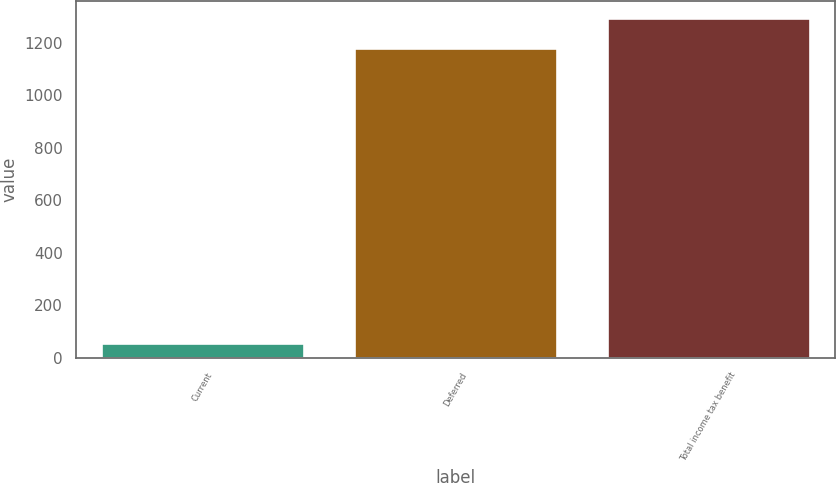Convert chart. <chart><loc_0><loc_0><loc_500><loc_500><bar_chart><fcel>Current<fcel>Deferred<fcel>Total income tax benefit<nl><fcel>58<fcel>1180<fcel>1292.9<nl></chart> 